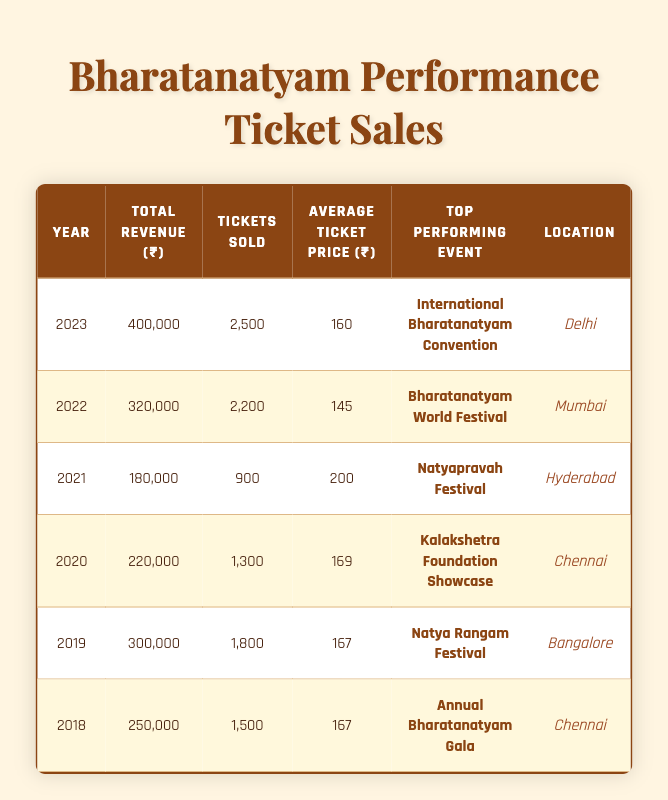What was the total revenue from ticket sales in 2023? In the table, under the year 2023, the total revenue is listed as 400,000.
Answer: 400,000 Which event generated the highest revenue in 2022? The top performing event in 2022 is the "Bharatanatyam World Festival," which is mentioned directly in the table.
Answer: Bharatanatyam World Festival How many tickets were sold for the Natyapravah Festival in 2021? The table lists the tickets sold for the Natyapravah Festival under the year 2021 as 900 tickets.
Answer: 900 What was the average ticket price in 2021? The average ticket price for the year 2021 is given as 200 in the table.
Answer: 200 What was the total revenue from ticket sales for Bharatanatyam performances from 2018 to 2020? For the years 2018 to 2020, the total revenues are 250,000 (2018), 300,000 (2019), and 220,000 (2020). Summing these values gives 250,000 + 300,000 + 220,000 = 770,000.
Answer: 770,000 Did the average ticket price increase from 2020 to 2021? In 2020, the average ticket price was 169, and in 2021, it rose to 200. Since 200 > 169, the average ticket price indeed increased.
Answer: Yes Which location had the highest ticket sales in 2023? The table states that in 2023, the top location for ticket sales was Delhi, related to the "International Bharatanatyam Convention."
Answer: Delhi How does the total revenue in 2022 compare to that in 2021? The total revenue for 2022 was 320,000, while in 2021 it was 180,000. 320,000 is greater than 180,000, showing that revenue in 2022 is higher.
Answer: 320,000 is higher What is the overall average ticket price from 2018 to 2023? The average ticket prices for the years are as follows: 167 (2018), 167 (2019), 169 (2020), 200 (2021), 145 (2022), and 160 (2023). Their total is 1,028 (sum of all) and dividing by 6 (number of years) gives 171.33.
Answer: 171.33 Was there a decline in ticket sales from 2019 to 2020? In 2019, tickets sold were 1800, but in 2020, it decreased to 1300. Since 1300 < 1800, there was indeed a decline in ticket sales between these years.
Answer: Yes What was the highest average ticket price recorded in the provided data? From the table, the highest average ticket price noted is 200 in the year 2021.
Answer: 200 